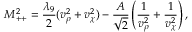Convert formula to latex. <formula><loc_0><loc_0><loc_500><loc_500>M _ { + + } ^ { 2 } = \frac { \lambda _ { 9 } } { 2 } ( v _ { \rho } ^ { 2 } + v _ { \chi } ^ { 2 } ) - \frac { A } { \sqrt { 2 } } \left ( \frac { 1 } { v _ { \rho } ^ { 2 } } + \frac { 1 } { v _ { \chi } ^ { 2 } } \right ) ,</formula> 